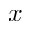<formula> <loc_0><loc_0><loc_500><loc_500>x</formula> 